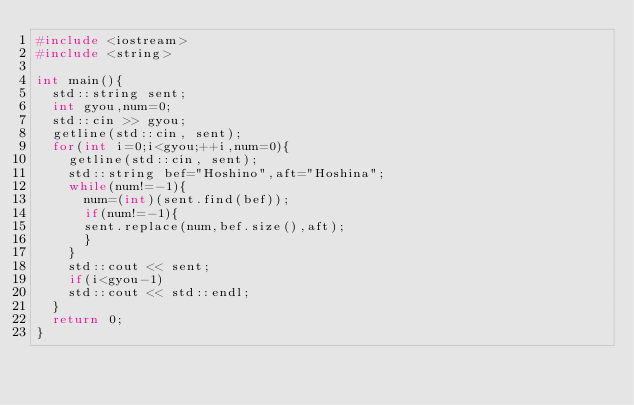<code> <loc_0><loc_0><loc_500><loc_500><_C++_>#include <iostream> 
#include <string> 

int main(){
  std::string sent;
  int gyou,num=0;
  std::cin >> gyou;
  getline(std::cin, sent);
  for(int i=0;i<gyou;++i,num=0){
    getline(std::cin, sent);
    std::string bef="Hoshino",aft="Hoshina";
    while(num!=-1){
      num=(int)(sent.find(bef));
      if(num!=-1){
      sent.replace(num,bef.size(),aft);
      }
    }
    std::cout << sent;
    if(i<gyou-1)
    std::cout << std::endl;
  }
  return 0; 
}</code> 